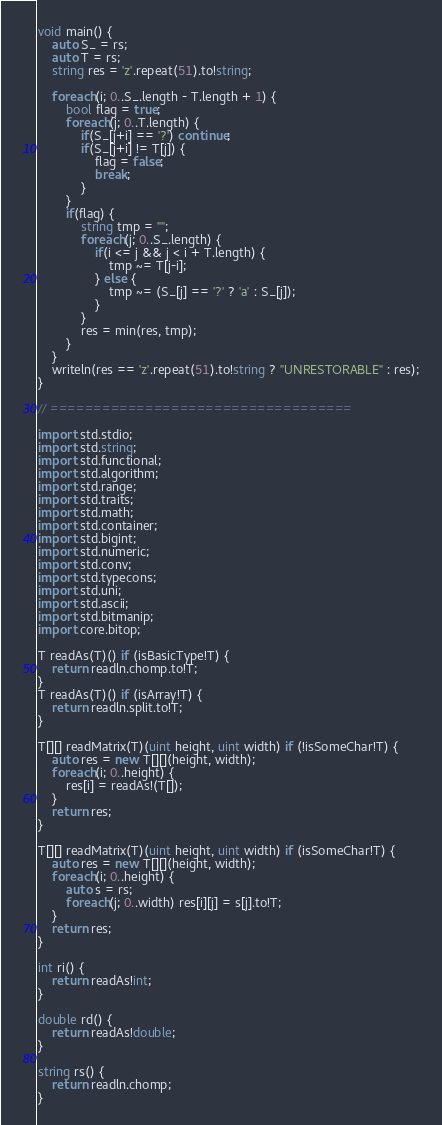<code> <loc_0><loc_0><loc_500><loc_500><_D_>void main() {
	auto S_ = rs;
	auto T = rs;
	string res = 'z'.repeat(51).to!string;

	foreach(i; 0..S_.length - T.length + 1) {
		bool flag = true;
		foreach(j; 0..T.length) {
			if(S_[j+i] == '?') continue;
			if(S_[j+i] != T[j]) {
				flag = false;
				break;
			}
		}
		if(flag) {
			string tmp = "";
			foreach(j; 0..S_.length) {
				if(i <= j && j < i + T.length) {
					tmp ~= T[j-i];
				} else {
					tmp ~= (S_[j] == '?' ? 'a' : S_[j]);
				}
			}
			res = min(res, tmp);
		}
	}
	writeln(res == 'z'.repeat(51).to!string ? "UNRESTORABLE" : res);
}

// ===================================

import std.stdio;
import std.string;
import std.functional;
import std.algorithm;
import std.range;
import std.traits;
import std.math;
import std.container;
import std.bigint;
import std.numeric;
import std.conv;
import std.typecons;
import std.uni;
import std.ascii;
import std.bitmanip;
import core.bitop;

T readAs(T)() if (isBasicType!T) {
	return readln.chomp.to!T;
}
T readAs(T)() if (isArray!T) {
	return readln.split.to!T;
}

T[][] readMatrix(T)(uint height, uint width) if (!isSomeChar!T) {
	auto res = new T[][](height, width);
	foreach(i; 0..height) {
		res[i] = readAs!(T[]);
	}
	return res;
}

T[][] readMatrix(T)(uint height, uint width) if (isSomeChar!T) {
	auto res = new T[][](height, width);
	foreach(i; 0..height) {
		auto s = rs;
		foreach(j; 0..width) res[i][j] = s[j].to!T;
	}
	return res;
}

int ri() {
	return readAs!int;
}

double rd() {
	return readAs!double;
}

string rs() {
	return readln.chomp;
}</code> 